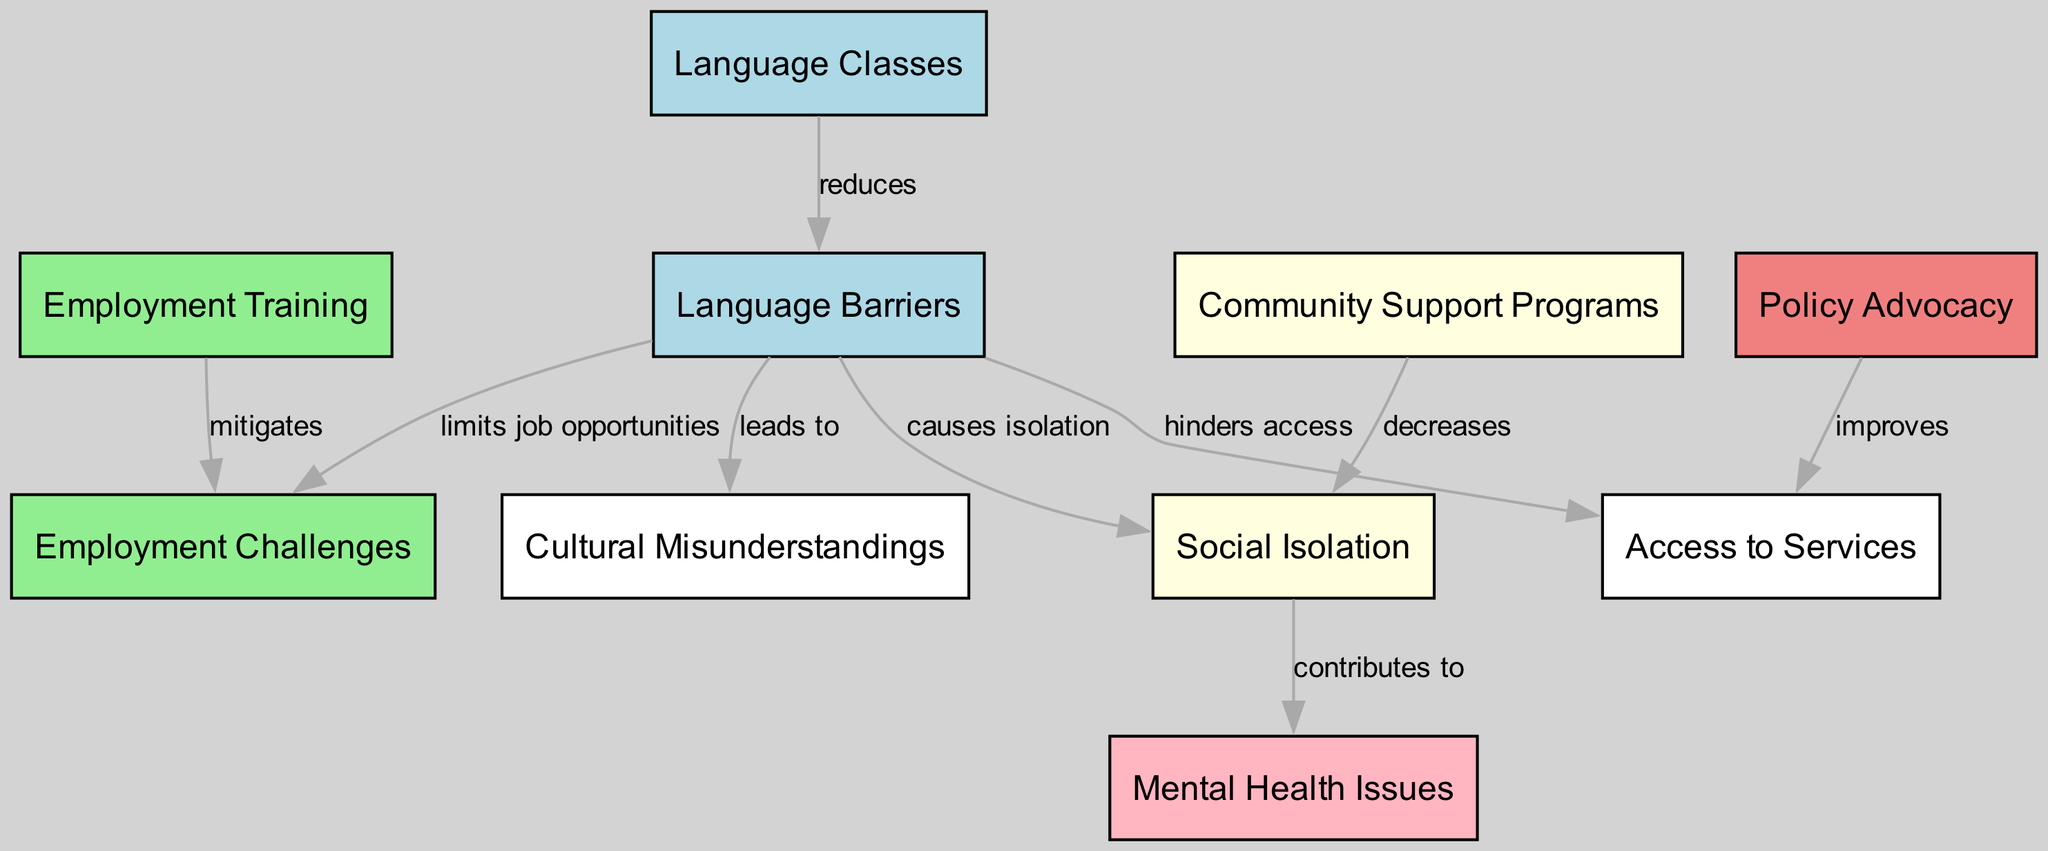What is the total number of nodes in the diagram? The diagram contains ten unique nodes as defined in the data structure. These nodes represent various aspects of language barriers and their impacts on Afghan interpreters.
Answer: ten How many edges connect to the "social isolation" node? The "social isolation" node has three edges connecting it to "language barriers," "mental health issues," and "community support programs," indicating its relational context within the diagram.
Answer: three What is the impact of language barriers on employment challenges? The diagram shows that language barriers "limits job opportunities," which directly influences the employment challenges faced by Afghan interpreters.
Answer: limits job opportunities Which program decreases social isolation? The "community support programs" node is connected to "social isolation," indicating that such programs serve to decrease feelings of isolation among Afghan interpreters.
Answer: community support programs What are the two outcomes of the "language barriers" node? The "language barriers" node leads to "employment challenges," "access to services," "social isolation," and "cultural misunderstandings," showcasing its multifaceted impact.
Answer: employment challenges, access to services, social isolation, cultural misunderstandings Which intervention improves access to services? The diagram indicates that "policy advocacy" improves access to services for Afghan interpreters overcoming the challenges posed by language barriers.
Answer: policy advocacy How are "language classes" related to "language barriers"? The "language classes" node is linked to the "language barriers" node, indicating that these classes help in reducing the impact of language barriers on interpreters.
Answer: reduces What contributes to mental health issues for Afghan interpreters? The connection from "social isolation" to "mental health issues" indicates that the experiences of isolation among interpreters contribute significantly to their mental health struggles.
Answer: contributes to How does employment training affect employment challenges? The "employment training" node is connected to "employment challenges" indicating that such training mitigates these challenges faced by Afghan interpreters.
Answer: mitigates 